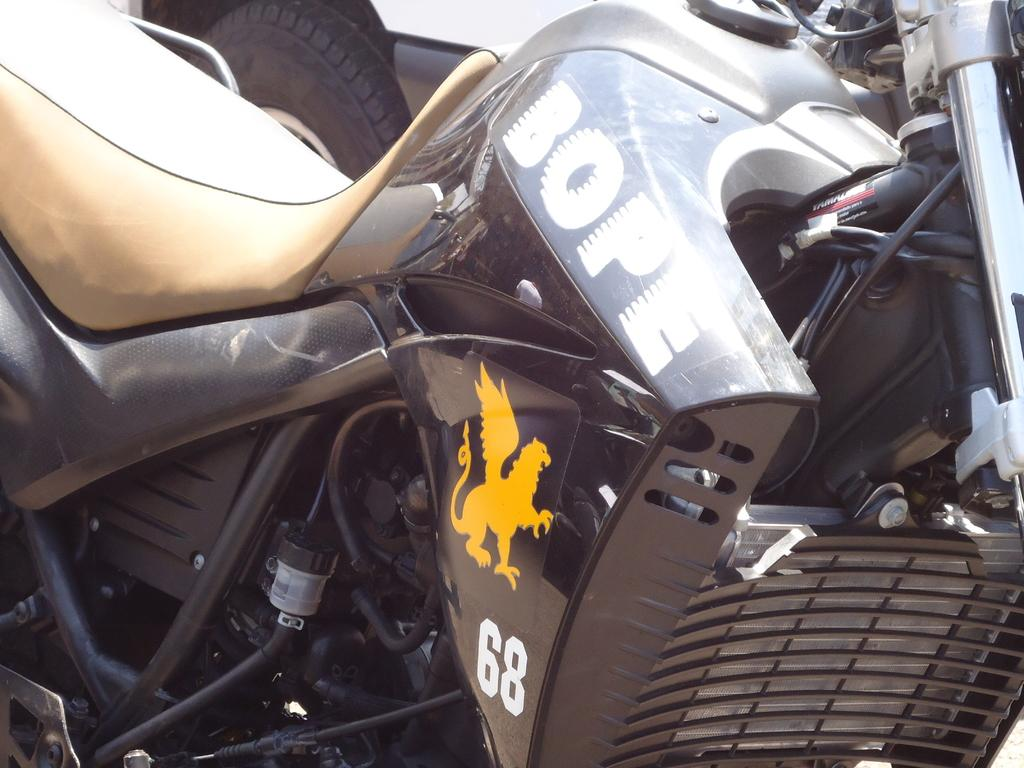What is the main subject in the foreground of the image? There is a bike in the foreground of the image. What can be seen in the background of the image? There is a car in the background of the image, which appears to be truncated or partially visible. What type of pencil is the mother using to draw the bike in the image? There is no mother or pencil present in the image; it features a bike in the foreground and a partially visible car in the background. 